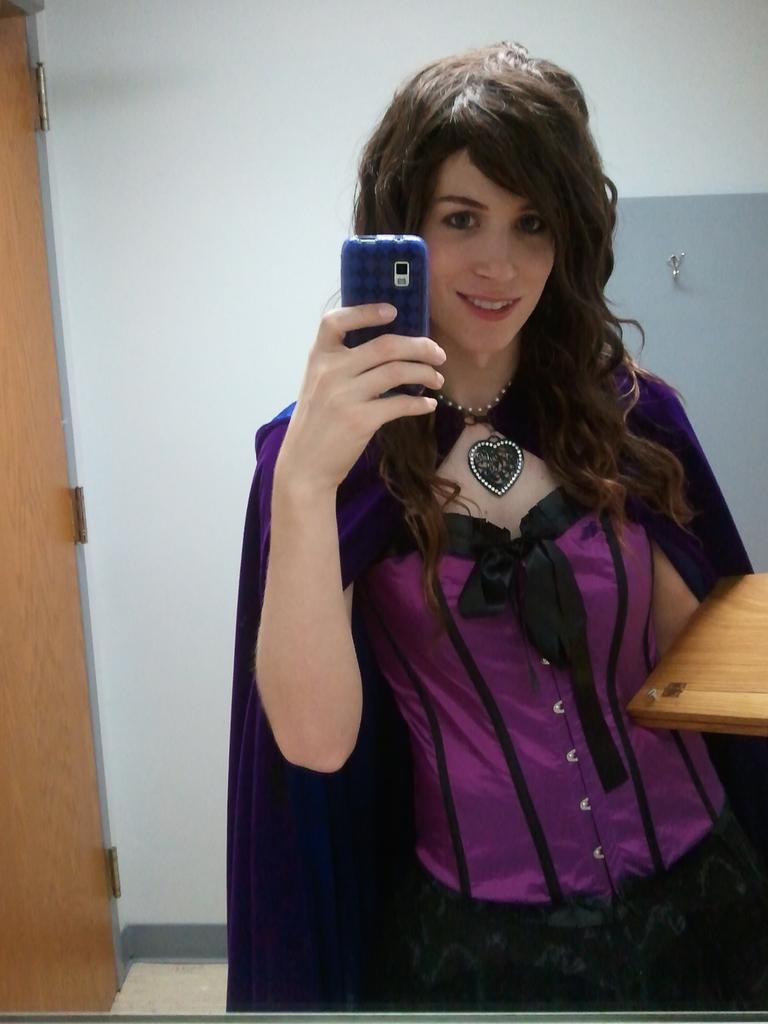Who is present in the image? There is a woman in the image. What is the woman holding in her hand? The woman is holding a mobile in her hand. What color is the top that the woman is wearing? The woman is wearing a brinjal color top. What expression does the woman have on her face? The woman is smiling. What type of rub is the woman applying to her skin in the image? There is no indication in the image that the woman is applying any rub to her skin. 